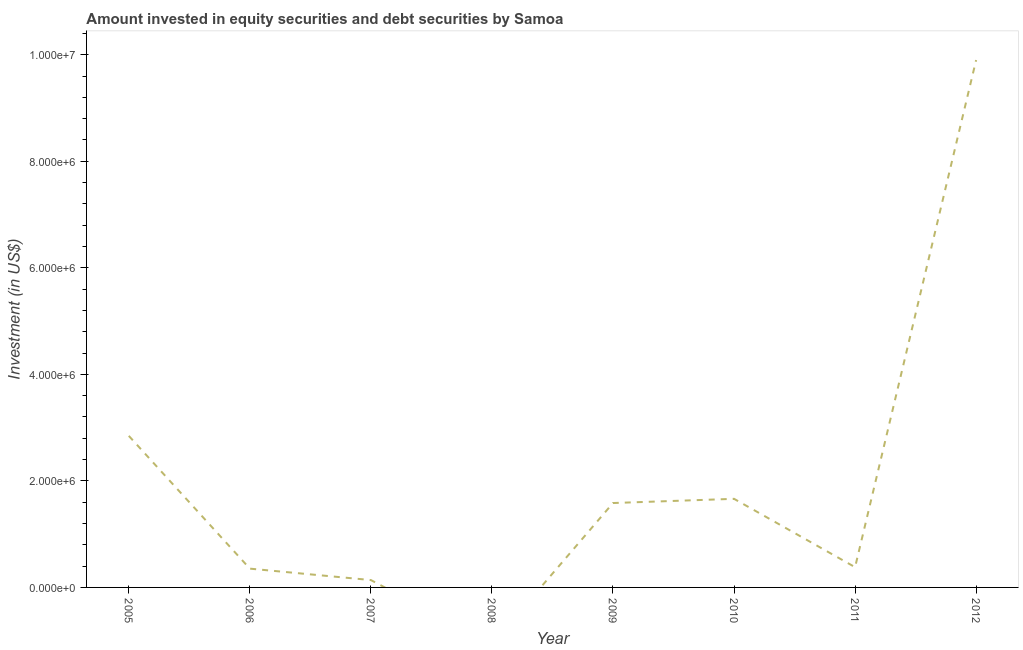What is the portfolio investment in 2008?
Provide a succinct answer. 0. Across all years, what is the maximum portfolio investment?
Your answer should be very brief. 9.90e+06. In which year was the portfolio investment maximum?
Offer a very short reply. 2012. What is the sum of the portfolio investment?
Give a very brief answer. 1.69e+07. What is the difference between the portfolio investment in 2007 and 2012?
Offer a terse response. -9.76e+06. What is the average portfolio investment per year?
Keep it short and to the point. 2.11e+06. What is the median portfolio investment?
Give a very brief answer. 9.82e+05. What is the ratio of the portfolio investment in 2005 to that in 2006?
Your answer should be compact. 8.07. Is the difference between the portfolio investment in 2005 and 2009 greater than the difference between any two years?
Your response must be concise. No. What is the difference between the highest and the second highest portfolio investment?
Your answer should be very brief. 7.06e+06. Is the sum of the portfolio investment in 2005 and 2010 greater than the maximum portfolio investment across all years?
Your response must be concise. No. What is the difference between the highest and the lowest portfolio investment?
Ensure brevity in your answer.  9.90e+06. In how many years, is the portfolio investment greater than the average portfolio investment taken over all years?
Provide a succinct answer. 2. Does the portfolio investment monotonically increase over the years?
Offer a terse response. No. How many lines are there?
Give a very brief answer. 1. How many years are there in the graph?
Your answer should be very brief. 8. Are the values on the major ticks of Y-axis written in scientific E-notation?
Offer a terse response. Yes. Does the graph contain grids?
Your answer should be very brief. No. What is the title of the graph?
Your response must be concise. Amount invested in equity securities and debt securities by Samoa. What is the label or title of the X-axis?
Provide a succinct answer. Year. What is the label or title of the Y-axis?
Offer a terse response. Investment (in US$). What is the Investment (in US$) in 2005?
Offer a very short reply. 2.85e+06. What is the Investment (in US$) of 2006?
Offer a terse response. 3.53e+05. What is the Investment (in US$) of 2007?
Give a very brief answer. 1.38e+05. What is the Investment (in US$) of 2009?
Your response must be concise. 1.58e+06. What is the Investment (in US$) in 2010?
Offer a terse response. 1.66e+06. What is the Investment (in US$) in 2011?
Give a very brief answer. 3.80e+05. What is the Investment (in US$) of 2012?
Your answer should be very brief. 9.90e+06. What is the difference between the Investment (in US$) in 2005 and 2006?
Your response must be concise. 2.49e+06. What is the difference between the Investment (in US$) in 2005 and 2007?
Make the answer very short. 2.71e+06. What is the difference between the Investment (in US$) in 2005 and 2009?
Ensure brevity in your answer.  1.26e+06. What is the difference between the Investment (in US$) in 2005 and 2010?
Provide a short and direct response. 1.18e+06. What is the difference between the Investment (in US$) in 2005 and 2011?
Ensure brevity in your answer.  2.47e+06. What is the difference between the Investment (in US$) in 2005 and 2012?
Offer a very short reply. -7.06e+06. What is the difference between the Investment (in US$) in 2006 and 2007?
Your response must be concise. 2.15e+05. What is the difference between the Investment (in US$) in 2006 and 2009?
Your answer should be very brief. -1.23e+06. What is the difference between the Investment (in US$) in 2006 and 2010?
Ensure brevity in your answer.  -1.31e+06. What is the difference between the Investment (in US$) in 2006 and 2011?
Provide a succinct answer. -2.75e+04. What is the difference between the Investment (in US$) in 2006 and 2012?
Your answer should be compact. -9.55e+06. What is the difference between the Investment (in US$) in 2007 and 2009?
Provide a short and direct response. -1.45e+06. What is the difference between the Investment (in US$) in 2007 and 2010?
Offer a very short reply. -1.53e+06. What is the difference between the Investment (in US$) in 2007 and 2011?
Give a very brief answer. -2.42e+05. What is the difference between the Investment (in US$) in 2007 and 2012?
Your response must be concise. -9.76e+06. What is the difference between the Investment (in US$) in 2009 and 2010?
Keep it short and to the point. -7.89e+04. What is the difference between the Investment (in US$) in 2009 and 2011?
Your response must be concise. 1.20e+06. What is the difference between the Investment (in US$) in 2009 and 2012?
Your answer should be compact. -8.32e+06. What is the difference between the Investment (in US$) in 2010 and 2011?
Offer a terse response. 1.28e+06. What is the difference between the Investment (in US$) in 2010 and 2012?
Keep it short and to the point. -8.24e+06. What is the difference between the Investment (in US$) in 2011 and 2012?
Your answer should be very brief. -9.52e+06. What is the ratio of the Investment (in US$) in 2005 to that in 2006?
Your answer should be compact. 8.07. What is the ratio of the Investment (in US$) in 2005 to that in 2007?
Your answer should be compact. 20.6. What is the ratio of the Investment (in US$) in 2005 to that in 2009?
Your response must be concise. 1.8. What is the ratio of the Investment (in US$) in 2005 to that in 2010?
Ensure brevity in your answer.  1.71. What is the ratio of the Investment (in US$) in 2005 to that in 2011?
Your answer should be very brief. 7.48. What is the ratio of the Investment (in US$) in 2005 to that in 2012?
Provide a short and direct response. 0.29. What is the ratio of the Investment (in US$) in 2006 to that in 2007?
Your answer should be very brief. 2.55. What is the ratio of the Investment (in US$) in 2006 to that in 2009?
Your response must be concise. 0.22. What is the ratio of the Investment (in US$) in 2006 to that in 2010?
Give a very brief answer. 0.21. What is the ratio of the Investment (in US$) in 2006 to that in 2011?
Make the answer very short. 0.93. What is the ratio of the Investment (in US$) in 2006 to that in 2012?
Make the answer very short. 0.04. What is the ratio of the Investment (in US$) in 2007 to that in 2009?
Your answer should be very brief. 0.09. What is the ratio of the Investment (in US$) in 2007 to that in 2010?
Offer a terse response. 0.08. What is the ratio of the Investment (in US$) in 2007 to that in 2011?
Keep it short and to the point. 0.36. What is the ratio of the Investment (in US$) in 2007 to that in 2012?
Make the answer very short. 0.01. What is the ratio of the Investment (in US$) in 2009 to that in 2010?
Keep it short and to the point. 0.95. What is the ratio of the Investment (in US$) in 2009 to that in 2011?
Ensure brevity in your answer.  4.17. What is the ratio of the Investment (in US$) in 2009 to that in 2012?
Your response must be concise. 0.16. What is the ratio of the Investment (in US$) in 2010 to that in 2011?
Your answer should be compact. 4.38. What is the ratio of the Investment (in US$) in 2010 to that in 2012?
Your response must be concise. 0.17. What is the ratio of the Investment (in US$) in 2011 to that in 2012?
Your answer should be very brief. 0.04. 